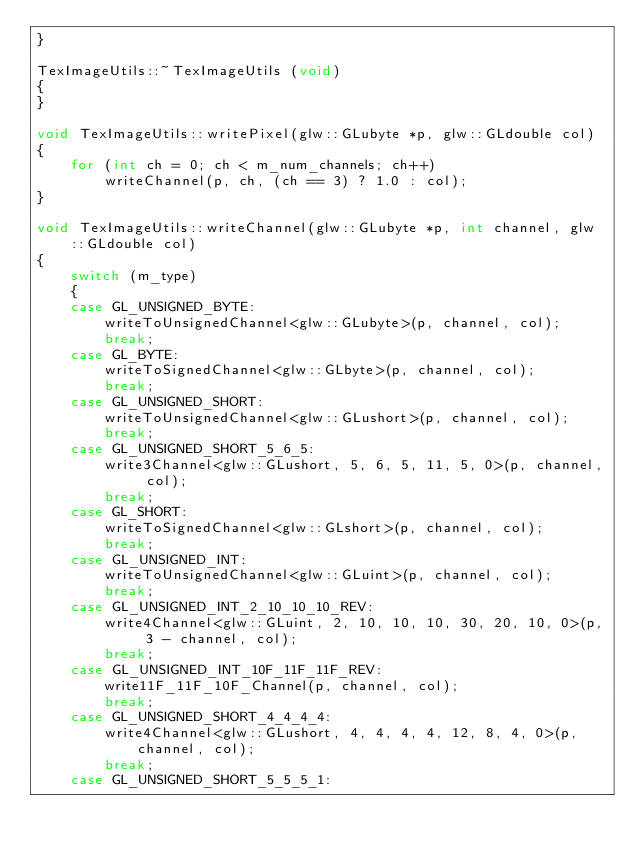Convert code to text. <code><loc_0><loc_0><loc_500><loc_500><_C++_>}

TexImageUtils::~TexImageUtils (void)
{
}

void TexImageUtils::writePixel(glw::GLubyte *p, glw::GLdouble col)
{
	for (int ch = 0; ch < m_num_channels; ch++)
		writeChannel(p, ch, (ch == 3) ? 1.0 : col);
}

void TexImageUtils::writeChannel(glw::GLubyte *p, int channel, glw::GLdouble col)
{
	switch (m_type)
	{
	case GL_UNSIGNED_BYTE:
		writeToUnsignedChannel<glw::GLubyte>(p, channel, col);
		break;
	case GL_BYTE:
		writeToSignedChannel<glw::GLbyte>(p, channel, col);
		break;
	case GL_UNSIGNED_SHORT:
		writeToUnsignedChannel<glw::GLushort>(p, channel, col);
		break;
	case GL_UNSIGNED_SHORT_5_6_5:
		write3Channel<glw::GLushort, 5, 6, 5, 11, 5, 0>(p, channel, col);
		break;
	case GL_SHORT:
		writeToSignedChannel<glw::GLshort>(p, channel, col);
		break;
	case GL_UNSIGNED_INT:
		writeToUnsignedChannel<glw::GLuint>(p, channel, col);
		break;
	case GL_UNSIGNED_INT_2_10_10_10_REV:
		write4Channel<glw::GLuint, 2, 10, 10, 10, 30, 20, 10, 0>(p, 3 - channel, col);
		break;
	case GL_UNSIGNED_INT_10F_11F_11F_REV:
		write11F_11F_10F_Channel(p, channel, col);
		break;
	case GL_UNSIGNED_SHORT_4_4_4_4:
		write4Channel<glw::GLushort, 4, 4, 4, 4, 12, 8, 4, 0>(p, channel, col);
		break;
	case GL_UNSIGNED_SHORT_5_5_5_1:</code> 